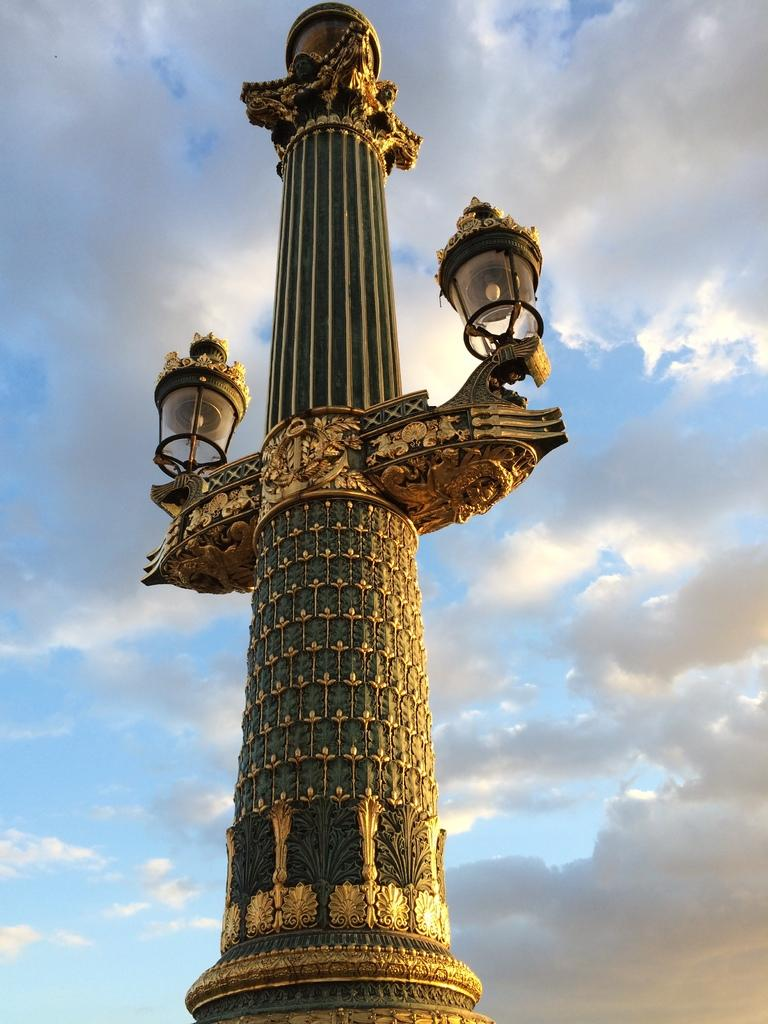What is located in the foreground of the picture? There is a street light in the foreground of the picture. How would you describe the weather in the image? The sky is sunny, which suggests a clear and bright day. What type of spark can be seen coming from the zoo in the image? There is no zoo present in the image, and therefore no spark can be seen coming from it. 